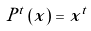<formula> <loc_0><loc_0><loc_500><loc_500>P ^ { t } \left ( x \right ) = x ^ { t }</formula> 